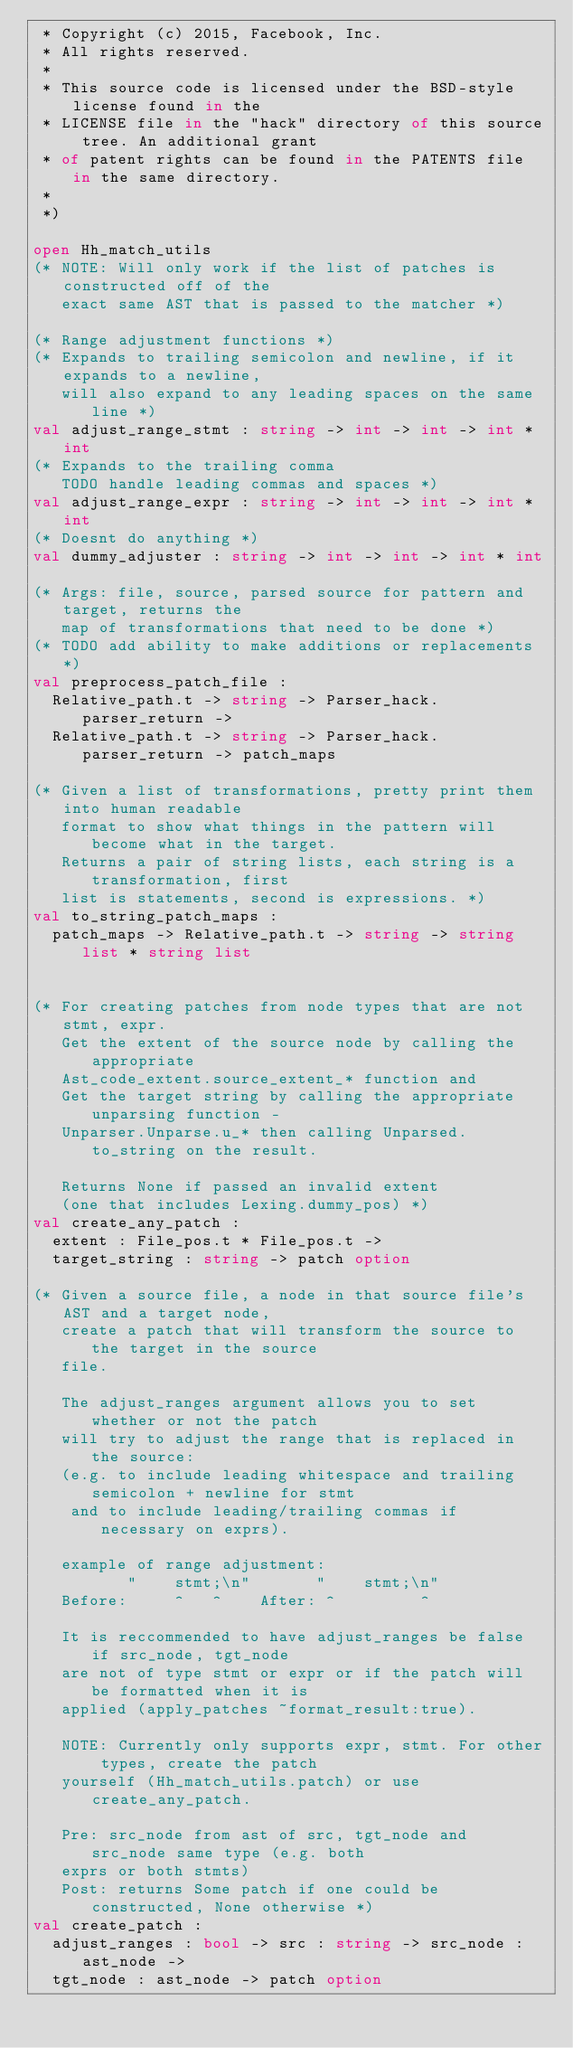Convert code to text. <code><loc_0><loc_0><loc_500><loc_500><_OCaml_> * Copyright (c) 2015, Facebook, Inc.
 * All rights reserved.
 *
 * This source code is licensed under the BSD-style license found in the
 * LICENSE file in the "hack" directory of this source tree. An additional grant
 * of patent rights can be found in the PATENTS file in the same directory.
 *
 *)

open Hh_match_utils
(* NOTE: Will only work if the list of patches is constructed off of the
   exact same AST that is passed to the matcher *)

(* Range adjustment functions *)
(* Expands to trailing semicolon and newline, if it expands to a newline,
   will also expand to any leading spaces on the same line *)
val adjust_range_stmt : string -> int -> int -> int * int
(* Expands to the trailing comma
   TODO handle leading commas and spaces *)
val adjust_range_expr : string -> int -> int -> int * int
(* Doesnt do anything *)
val dummy_adjuster : string -> int -> int -> int * int

(* Args: file, source, parsed source for pattern and target, returns the
   map of transformations that need to be done *)
(* TODO add ability to make additions or replacements *)
val preprocess_patch_file :
  Relative_path.t -> string -> Parser_hack.parser_return ->
  Relative_path.t -> string -> Parser_hack.parser_return -> patch_maps

(* Given a list of transformations, pretty print them into human readable
   format to show what things in the pattern will become what in the target.
   Returns a pair of string lists, each string is a transformation, first
   list is statements, second is expressions. *)
val to_string_patch_maps :
  patch_maps -> Relative_path.t -> string -> string list * string list


(* For creating patches from node types that are not stmt, expr.
   Get the extent of the source node by calling the appropriate
   Ast_code_extent.source_extent_* function and
   Get the target string by calling the appropriate unparsing function -
   Unparser.Unparse.u_* then calling Unparsed.to_string on the result.

   Returns None if passed an invalid extent
   (one that includes Lexing.dummy_pos) *)
val create_any_patch :
  extent : File_pos.t * File_pos.t ->
  target_string : string -> patch option

(* Given a source file, a node in that source file's AST and a target node,
   create a patch that will transform the source to the target in the source
   file.

   The adjust_ranges argument allows you to set whether or not the patch
   will try to adjust the range that is replaced in the source:
   (e.g. to include leading whitespace and trailing semicolon + newline for stmt
    and to include leading/trailing commas if necessary on exprs).

   example of range adjustment:
          "    stmt;\n"       "    stmt;\n"
   Before:     ^   ^    After: ^         ^

   It is reccommended to have adjust_ranges be false if src_node, tgt_node
   are not of type stmt or expr or if the patch will be formatted when it is
   applied (apply_patches ~format_result:true).

   NOTE: Currently only supports expr, stmt. For other types, create the patch
   yourself (Hh_match_utils.patch) or use create_any_patch.

   Pre: src_node from ast of src, tgt_node and src_node same type (e.g. both
   exprs or both stmts)
   Post: returns Some patch if one could be constructed, None otherwise *)
val create_patch :
  adjust_ranges : bool -> src : string -> src_node : ast_node ->
  tgt_node : ast_node -> patch option
</code> 